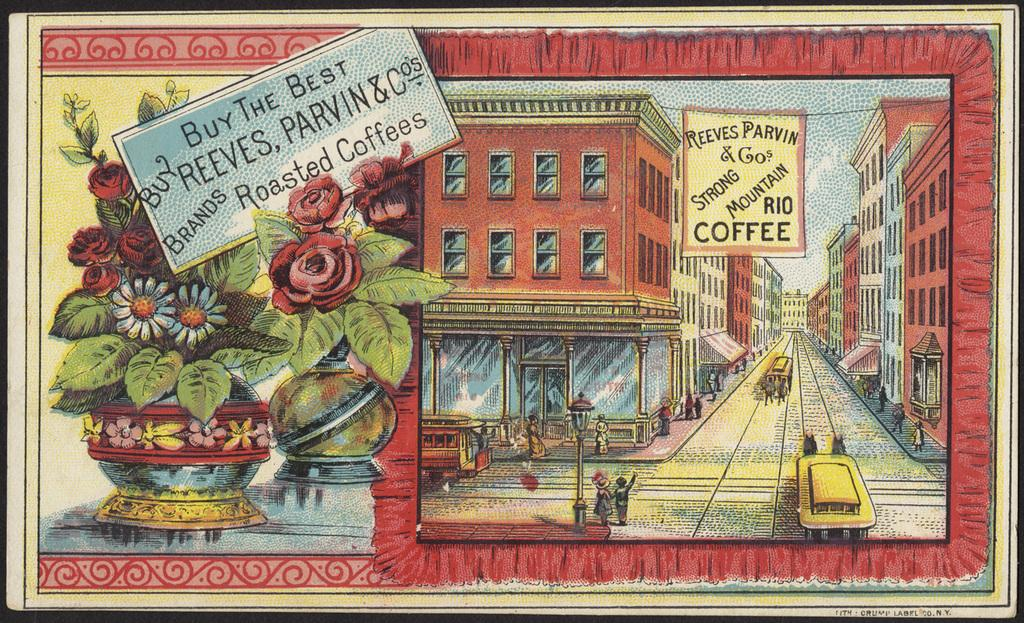<image>
Give a short and clear explanation of the subsequent image. Reeves Parvin & Cos sells strong mountain Rio coffee according to their sign on their building. 